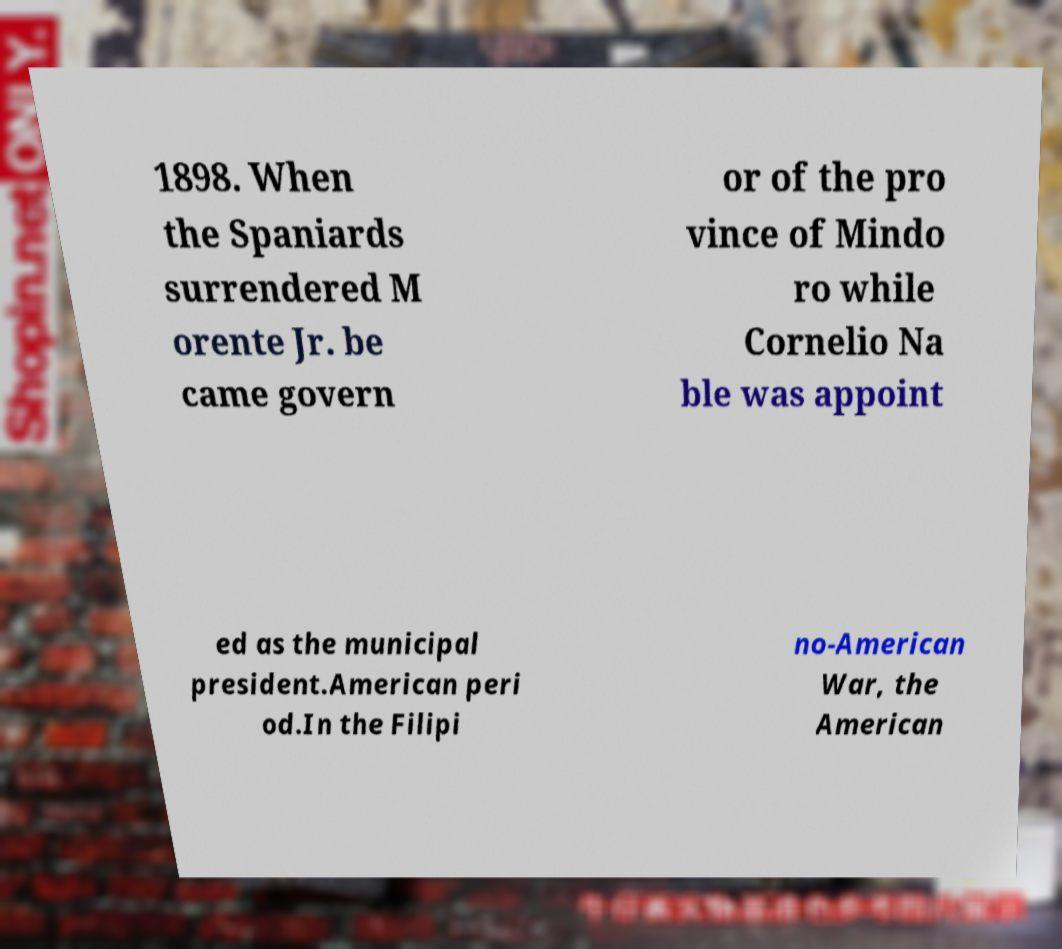Please read and relay the text visible in this image. What does it say? 1898. When the Spaniards surrendered M orente Jr. be came govern or of the pro vince of Mindo ro while Cornelio Na ble was appoint ed as the municipal president.American peri od.In the Filipi no-American War, the American 